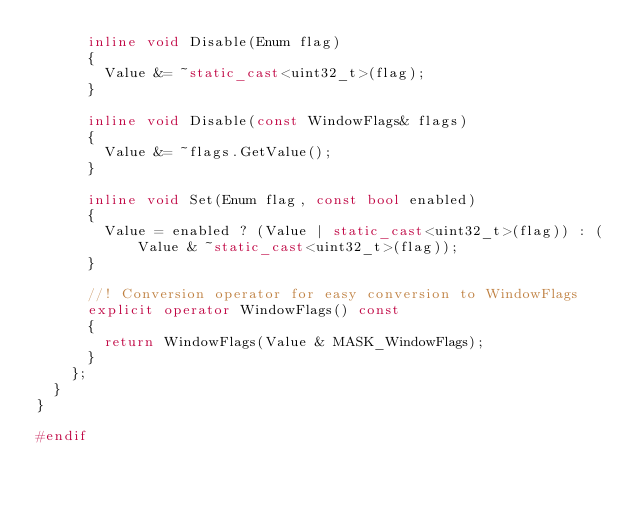Convert code to text. <code><loc_0><loc_0><loc_500><loc_500><_C++_>      inline void Disable(Enum flag)
      {
        Value &= ~static_cast<uint32_t>(flag);
      }

      inline void Disable(const WindowFlags& flags)
      {
        Value &= ~flags.GetValue();
      }

      inline void Set(Enum flag, const bool enabled)
      {
        Value = enabled ? (Value | static_cast<uint32_t>(flag)) : (Value & ~static_cast<uint32_t>(flag));
      }

      //! Conversion operator for easy conversion to WindowFlags
      explicit operator WindowFlags() const
      {
        return WindowFlags(Value & MASK_WindowFlags);
      }
    };
  }
}

#endif
</code> 